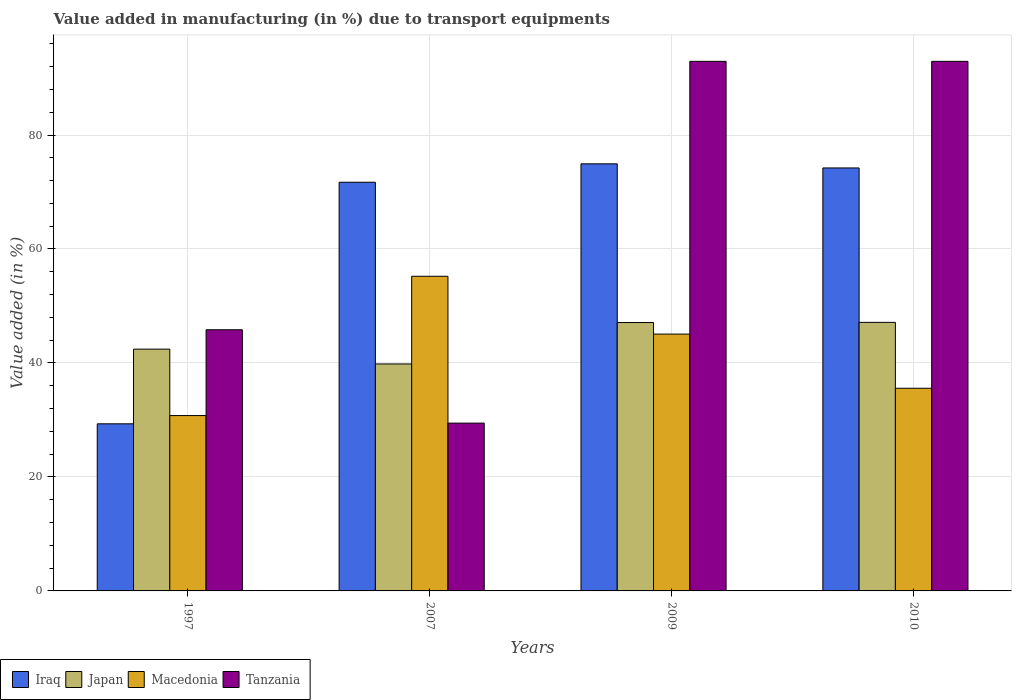How many different coloured bars are there?
Offer a terse response. 4. Are the number of bars per tick equal to the number of legend labels?
Provide a short and direct response. Yes. Are the number of bars on each tick of the X-axis equal?
Offer a terse response. Yes. How many bars are there on the 2nd tick from the left?
Make the answer very short. 4. In how many cases, is the number of bars for a given year not equal to the number of legend labels?
Keep it short and to the point. 0. What is the percentage of value added in manufacturing due to transport equipments in Tanzania in 2010?
Your answer should be very brief. 92.93. Across all years, what is the maximum percentage of value added in manufacturing due to transport equipments in Iraq?
Offer a very short reply. 74.94. Across all years, what is the minimum percentage of value added in manufacturing due to transport equipments in Tanzania?
Your answer should be very brief. 29.44. What is the total percentage of value added in manufacturing due to transport equipments in Iraq in the graph?
Ensure brevity in your answer.  250.2. What is the difference between the percentage of value added in manufacturing due to transport equipments in Tanzania in 1997 and that in 2007?
Make the answer very short. 16.38. What is the difference between the percentage of value added in manufacturing due to transport equipments in Macedonia in 2010 and the percentage of value added in manufacturing due to transport equipments in Iraq in 2009?
Ensure brevity in your answer.  -39.38. What is the average percentage of value added in manufacturing due to transport equipments in Iraq per year?
Ensure brevity in your answer.  62.55. In the year 2010, what is the difference between the percentage of value added in manufacturing due to transport equipments in Iraq and percentage of value added in manufacturing due to transport equipments in Japan?
Your response must be concise. 27.1. What is the ratio of the percentage of value added in manufacturing due to transport equipments in Japan in 2009 to that in 2010?
Provide a succinct answer. 1. Is the percentage of value added in manufacturing due to transport equipments in Japan in 1997 less than that in 2007?
Give a very brief answer. No. Is the difference between the percentage of value added in manufacturing due to transport equipments in Iraq in 1997 and 2009 greater than the difference between the percentage of value added in manufacturing due to transport equipments in Japan in 1997 and 2009?
Give a very brief answer. No. What is the difference between the highest and the second highest percentage of value added in manufacturing due to transport equipments in Iraq?
Provide a succinct answer. 0.72. What is the difference between the highest and the lowest percentage of value added in manufacturing due to transport equipments in Japan?
Provide a succinct answer. 7.3. In how many years, is the percentage of value added in manufacturing due to transport equipments in Japan greater than the average percentage of value added in manufacturing due to transport equipments in Japan taken over all years?
Give a very brief answer. 2. What does the 3rd bar from the right in 2007 represents?
Provide a succinct answer. Japan. Is it the case that in every year, the sum of the percentage of value added in manufacturing due to transport equipments in Japan and percentage of value added in manufacturing due to transport equipments in Tanzania is greater than the percentage of value added in manufacturing due to transport equipments in Macedonia?
Give a very brief answer. Yes. How many bars are there?
Ensure brevity in your answer.  16. What is the difference between two consecutive major ticks on the Y-axis?
Give a very brief answer. 20. Are the values on the major ticks of Y-axis written in scientific E-notation?
Keep it short and to the point. No. How many legend labels are there?
Ensure brevity in your answer.  4. What is the title of the graph?
Make the answer very short. Value added in manufacturing (in %) due to transport equipments. Does "Burundi" appear as one of the legend labels in the graph?
Your response must be concise. No. What is the label or title of the X-axis?
Make the answer very short. Years. What is the label or title of the Y-axis?
Provide a succinct answer. Value added (in %). What is the Value added (in %) in Iraq in 1997?
Offer a very short reply. 29.32. What is the Value added (in %) of Japan in 1997?
Make the answer very short. 42.43. What is the Value added (in %) of Macedonia in 1997?
Ensure brevity in your answer.  30.77. What is the Value added (in %) in Tanzania in 1997?
Provide a short and direct response. 45.83. What is the Value added (in %) in Iraq in 2007?
Your response must be concise. 71.71. What is the Value added (in %) of Japan in 2007?
Offer a terse response. 39.83. What is the Value added (in %) of Macedonia in 2007?
Provide a short and direct response. 55.21. What is the Value added (in %) of Tanzania in 2007?
Provide a succinct answer. 29.44. What is the Value added (in %) in Iraq in 2009?
Your answer should be compact. 74.94. What is the Value added (in %) in Japan in 2009?
Give a very brief answer. 47.1. What is the Value added (in %) in Macedonia in 2009?
Keep it short and to the point. 45.07. What is the Value added (in %) of Tanzania in 2009?
Keep it short and to the point. 92.93. What is the Value added (in %) in Iraq in 2010?
Give a very brief answer. 74.22. What is the Value added (in %) in Japan in 2010?
Keep it short and to the point. 47.12. What is the Value added (in %) of Macedonia in 2010?
Keep it short and to the point. 35.56. What is the Value added (in %) in Tanzania in 2010?
Your answer should be compact. 92.93. Across all years, what is the maximum Value added (in %) of Iraq?
Offer a very short reply. 74.94. Across all years, what is the maximum Value added (in %) of Japan?
Offer a terse response. 47.12. Across all years, what is the maximum Value added (in %) of Macedonia?
Your answer should be compact. 55.21. Across all years, what is the maximum Value added (in %) of Tanzania?
Your answer should be compact. 92.93. Across all years, what is the minimum Value added (in %) of Iraq?
Provide a succinct answer. 29.32. Across all years, what is the minimum Value added (in %) in Japan?
Make the answer very short. 39.83. Across all years, what is the minimum Value added (in %) in Macedonia?
Give a very brief answer. 30.77. Across all years, what is the minimum Value added (in %) in Tanzania?
Give a very brief answer. 29.44. What is the total Value added (in %) of Iraq in the graph?
Your answer should be very brief. 250.2. What is the total Value added (in %) of Japan in the graph?
Offer a terse response. 176.47. What is the total Value added (in %) of Macedonia in the graph?
Your answer should be very brief. 166.61. What is the total Value added (in %) in Tanzania in the graph?
Ensure brevity in your answer.  261.12. What is the difference between the Value added (in %) of Iraq in 1997 and that in 2007?
Make the answer very short. -42.39. What is the difference between the Value added (in %) of Japan in 1997 and that in 2007?
Keep it short and to the point. 2.6. What is the difference between the Value added (in %) of Macedonia in 1997 and that in 2007?
Ensure brevity in your answer.  -24.44. What is the difference between the Value added (in %) in Tanzania in 1997 and that in 2007?
Your answer should be very brief. 16.38. What is the difference between the Value added (in %) of Iraq in 1997 and that in 2009?
Your answer should be compact. -45.62. What is the difference between the Value added (in %) in Japan in 1997 and that in 2009?
Offer a very short reply. -4.67. What is the difference between the Value added (in %) in Macedonia in 1997 and that in 2009?
Your response must be concise. -14.3. What is the difference between the Value added (in %) of Tanzania in 1997 and that in 2009?
Offer a very short reply. -47.1. What is the difference between the Value added (in %) in Iraq in 1997 and that in 2010?
Your answer should be very brief. -44.9. What is the difference between the Value added (in %) in Japan in 1997 and that in 2010?
Your response must be concise. -4.7. What is the difference between the Value added (in %) in Macedonia in 1997 and that in 2010?
Ensure brevity in your answer.  -4.79. What is the difference between the Value added (in %) of Tanzania in 1997 and that in 2010?
Offer a very short reply. -47.1. What is the difference between the Value added (in %) of Iraq in 2007 and that in 2009?
Your response must be concise. -3.23. What is the difference between the Value added (in %) in Japan in 2007 and that in 2009?
Give a very brief answer. -7.27. What is the difference between the Value added (in %) in Macedonia in 2007 and that in 2009?
Your response must be concise. 10.15. What is the difference between the Value added (in %) in Tanzania in 2007 and that in 2009?
Offer a terse response. -63.48. What is the difference between the Value added (in %) in Iraq in 2007 and that in 2010?
Offer a terse response. -2.51. What is the difference between the Value added (in %) of Japan in 2007 and that in 2010?
Give a very brief answer. -7.3. What is the difference between the Value added (in %) in Macedonia in 2007 and that in 2010?
Your answer should be compact. 19.65. What is the difference between the Value added (in %) in Tanzania in 2007 and that in 2010?
Provide a short and direct response. -63.48. What is the difference between the Value added (in %) of Iraq in 2009 and that in 2010?
Ensure brevity in your answer.  0.72. What is the difference between the Value added (in %) in Japan in 2009 and that in 2010?
Your response must be concise. -0.03. What is the difference between the Value added (in %) in Macedonia in 2009 and that in 2010?
Give a very brief answer. 9.51. What is the difference between the Value added (in %) of Tanzania in 2009 and that in 2010?
Ensure brevity in your answer.  -0. What is the difference between the Value added (in %) in Iraq in 1997 and the Value added (in %) in Japan in 2007?
Provide a succinct answer. -10.5. What is the difference between the Value added (in %) of Iraq in 1997 and the Value added (in %) of Macedonia in 2007?
Ensure brevity in your answer.  -25.89. What is the difference between the Value added (in %) in Iraq in 1997 and the Value added (in %) in Tanzania in 2007?
Keep it short and to the point. -0.12. What is the difference between the Value added (in %) of Japan in 1997 and the Value added (in %) of Macedonia in 2007?
Make the answer very short. -12.79. What is the difference between the Value added (in %) of Japan in 1997 and the Value added (in %) of Tanzania in 2007?
Provide a short and direct response. 12.98. What is the difference between the Value added (in %) of Macedonia in 1997 and the Value added (in %) of Tanzania in 2007?
Give a very brief answer. 1.33. What is the difference between the Value added (in %) of Iraq in 1997 and the Value added (in %) of Japan in 2009?
Your answer should be compact. -17.78. What is the difference between the Value added (in %) in Iraq in 1997 and the Value added (in %) in Macedonia in 2009?
Make the answer very short. -15.74. What is the difference between the Value added (in %) in Iraq in 1997 and the Value added (in %) in Tanzania in 2009?
Your answer should be very brief. -63.6. What is the difference between the Value added (in %) in Japan in 1997 and the Value added (in %) in Macedonia in 2009?
Your answer should be very brief. -2.64. What is the difference between the Value added (in %) of Japan in 1997 and the Value added (in %) of Tanzania in 2009?
Your answer should be compact. -50.5. What is the difference between the Value added (in %) in Macedonia in 1997 and the Value added (in %) in Tanzania in 2009?
Your answer should be compact. -62.15. What is the difference between the Value added (in %) in Iraq in 1997 and the Value added (in %) in Japan in 2010?
Your answer should be very brief. -17.8. What is the difference between the Value added (in %) of Iraq in 1997 and the Value added (in %) of Macedonia in 2010?
Ensure brevity in your answer.  -6.24. What is the difference between the Value added (in %) in Iraq in 1997 and the Value added (in %) in Tanzania in 2010?
Give a very brief answer. -63.6. What is the difference between the Value added (in %) in Japan in 1997 and the Value added (in %) in Macedonia in 2010?
Ensure brevity in your answer.  6.86. What is the difference between the Value added (in %) in Japan in 1997 and the Value added (in %) in Tanzania in 2010?
Your answer should be compact. -50.5. What is the difference between the Value added (in %) in Macedonia in 1997 and the Value added (in %) in Tanzania in 2010?
Provide a succinct answer. -62.15. What is the difference between the Value added (in %) in Iraq in 2007 and the Value added (in %) in Japan in 2009?
Give a very brief answer. 24.62. What is the difference between the Value added (in %) of Iraq in 2007 and the Value added (in %) of Macedonia in 2009?
Offer a very short reply. 26.65. What is the difference between the Value added (in %) in Iraq in 2007 and the Value added (in %) in Tanzania in 2009?
Provide a short and direct response. -21.21. What is the difference between the Value added (in %) in Japan in 2007 and the Value added (in %) in Macedonia in 2009?
Offer a terse response. -5.24. What is the difference between the Value added (in %) in Japan in 2007 and the Value added (in %) in Tanzania in 2009?
Your response must be concise. -53.1. What is the difference between the Value added (in %) of Macedonia in 2007 and the Value added (in %) of Tanzania in 2009?
Offer a very short reply. -37.71. What is the difference between the Value added (in %) in Iraq in 2007 and the Value added (in %) in Japan in 2010?
Provide a succinct answer. 24.59. What is the difference between the Value added (in %) of Iraq in 2007 and the Value added (in %) of Macedonia in 2010?
Ensure brevity in your answer.  36.15. What is the difference between the Value added (in %) of Iraq in 2007 and the Value added (in %) of Tanzania in 2010?
Your answer should be compact. -21.21. What is the difference between the Value added (in %) in Japan in 2007 and the Value added (in %) in Macedonia in 2010?
Give a very brief answer. 4.26. What is the difference between the Value added (in %) in Japan in 2007 and the Value added (in %) in Tanzania in 2010?
Provide a succinct answer. -53.1. What is the difference between the Value added (in %) of Macedonia in 2007 and the Value added (in %) of Tanzania in 2010?
Offer a very short reply. -37.71. What is the difference between the Value added (in %) of Iraq in 2009 and the Value added (in %) of Japan in 2010?
Your answer should be very brief. 27.82. What is the difference between the Value added (in %) in Iraq in 2009 and the Value added (in %) in Macedonia in 2010?
Offer a very short reply. 39.38. What is the difference between the Value added (in %) in Iraq in 2009 and the Value added (in %) in Tanzania in 2010?
Provide a short and direct response. -17.98. What is the difference between the Value added (in %) in Japan in 2009 and the Value added (in %) in Macedonia in 2010?
Offer a very short reply. 11.54. What is the difference between the Value added (in %) of Japan in 2009 and the Value added (in %) of Tanzania in 2010?
Offer a terse response. -45.83. What is the difference between the Value added (in %) in Macedonia in 2009 and the Value added (in %) in Tanzania in 2010?
Ensure brevity in your answer.  -47.86. What is the average Value added (in %) of Iraq per year?
Make the answer very short. 62.55. What is the average Value added (in %) in Japan per year?
Keep it short and to the point. 44.12. What is the average Value added (in %) of Macedonia per year?
Provide a short and direct response. 41.65. What is the average Value added (in %) of Tanzania per year?
Offer a very short reply. 65.28. In the year 1997, what is the difference between the Value added (in %) of Iraq and Value added (in %) of Japan?
Give a very brief answer. -13.1. In the year 1997, what is the difference between the Value added (in %) of Iraq and Value added (in %) of Macedonia?
Offer a terse response. -1.45. In the year 1997, what is the difference between the Value added (in %) of Iraq and Value added (in %) of Tanzania?
Provide a short and direct response. -16.5. In the year 1997, what is the difference between the Value added (in %) of Japan and Value added (in %) of Macedonia?
Offer a terse response. 11.66. In the year 1997, what is the difference between the Value added (in %) in Japan and Value added (in %) in Tanzania?
Your answer should be compact. -3.4. In the year 1997, what is the difference between the Value added (in %) in Macedonia and Value added (in %) in Tanzania?
Give a very brief answer. -15.06. In the year 2007, what is the difference between the Value added (in %) in Iraq and Value added (in %) in Japan?
Your response must be concise. 31.89. In the year 2007, what is the difference between the Value added (in %) in Iraq and Value added (in %) in Macedonia?
Give a very brief answer. 16.5. In the year 2007, what is the difference between the Value added (in %) in Iraq and Value added (in %) in Tanzania?
Offer a terse response. 42.27. In the year 2007, what is the difference between the Value added (in %) in Japan and Value added (in %) in Macedonia?
Ensure brevity in your answer.  -15.39. In the year 2007, what is the difference between the Value added (in %) of Japan and Value added (in %) of Tanzania?
Your response must be concise. 10.38. In the year 2007, what is the difference between the Value added (in %) in Macedonia and Value added (in %) in Tanzania?
Your answer should be very brief. 25.77. In the year 2009, what is the difference between the Value added (in %) of Iraq and Value added (in %) of Japan?
Provide a short and direct response. 27.85. In the year 2009, what is the difference between the Value added (in %) in Iraq and Value added (in %) in Macedonia?
Your response must be concise. 29.88. In the year 2009, what is the difference between the Value added (in %) in Iraq and Value added (in %) in Tanzania?
Provide a succinct answer. -17.98. In the year 2009, what is the difference between the Value added (in %) in Japan and Value added (in %) in Macedonia?
Keep it short and to the point. 2.03. In the year 2009, what is the difference between the Value added (in %) in Japan and Value added (in %) in Tanzania?
Your answer should be compact. -45.83. In the year 2009, what is the difference between the Value added (in %) of Macedonia and Value added (in %) of Tanzania?
Your answer should be compact. -47.86. In the year 2010, what is the difference between the Value added (in %) of Iraq and Value added (in %) of Japan?
Offer a terse response. 27.1. In the year 2010, what is the difference between the Value added (in %) in Iraq and Value added (in %) in Macedonia?
Your answer should be compact. 38.66. In the year 2010, what is the difference between the Value added (in %) in Iraq and Value added (in %) in Tanzania?
Provide a succinct answer. -18.7. In the year 2010, what is the difference between the Value added (in %) in Japan and Value added (in %) in Macedonia?
Your answer should be very brief. 11.56. In the year 2010, what is the difference between the Value added (in %) of Japan and Value added (in %) of Tanzania?
Keep it short and to the point. -45.8. In the year 2010, what is the difference between the Value added (in %) in Macedonia and Value added (in %) in Tanzania?
Give a very brief answer. -57.36. What is the ratio of the Value added (in %) of Iraq in 1997 to that in 2007?
Make the answer very short. 0.41. What is the ratio of the Value added (in %) of Japan in 1997 to that in 2007?
Offer a terse response. 1.07. What is the ratio of the Value added (in %) in Macedonia in 1997 to that in 2007?
Provide a succinct answer. 0.56. What is the ratio of the Value added (in %) of Tanzania in 1997 to that in 2007?
Your answer should be very brief. 1.56. What is the ratio of the Value added (in %) in Iraq in 1997 to that in 2009?
Provide a succinct answer. 0.39. What is the ratio of the Value added (in %) of Japan in 1997 to that in 2009?
Keep it short and to the point. 0.9. What is the ratio of the Value added (in %) of Macedonia in 1997 to that in 2009?
Ensure brevity in your answer.  0.68. What is the ratio of the Value added (in %) of Tanzania in 1997 to that in 2009?
Give a very brief answer. 0.49. What is the ratio of the Value added (in %) of Iraq in 1997 to that in 2010?
Keep it short and to the point. 0.4. What is the ratio of the Value added (in %) of Japan in 1997 to that in 2010?
Give a very brief answer. 0.9. What is the ratio of the Value added (in %) in Macedonia in 1997 to that in 2010?
Provide a short and direct response. 0.87. What is the ratio of the Value added (in %) in Tanzania in 1997 to that in 2010?
Provide a succinct answer. 0.49. What is the ratio of the Value added (in %) in Iraq in 2007 to that in 2009?
Offer a terse response. 0.96. What is the ratio of the Value added (in %) in Japan in 2007 to that in 2009?
Your response must be concise. 0.85. What is the ratio of the Value added (in %) in Macedonia in 2007 to that in 2009?
Provide a short and direct response. 1.23. What is the ratio of the Value added (in %) of Tanzania in 2007 to that in 2009?
Provide a succinct answer. 0.32. What is the ratio of the Value added (in %) of Iraq in 2007 to that in 2010?
Your response must be concise. 0.97. What is the ratio of the Value added (in %) of Japan in 2007 to that in 2010?
Keep it short and to the point. 0.85. What is the ratio of the Value added (in %) in Macedonia in 2007 to that in 2010?
Provide a short and direct response. 1.55. What is the ratio of the Value added (in %) in Tanzania in 2007 to that in 2010?
Make the answer very short. 0.32. What is the ratio of the Value added (in %) of Iraq in 2009 to that in 2010?
Offer a very short reply. 1.01. What is the ratio of the Value added (in %) in Macedonia in 2009 to that in 2010?
Make the answer very short. 1.27. What is the difference between the highest and the second highest Value added (in %) in Iraq?
Your answer should be very brief. 0.72. What is the difference between the highest and the second highest Value added (in %) in Japan?
Offer a very short reply. 0.03. What is the difference between the highest and the second highest Value added (in %) of Macedonia?
Your answer should be very brief. 10.15. What is the difference between the highest and the second highest Value added (in %) of Tanzania?
Provide a succinct answer. 0. What is the difference between the highest and the lowest Value added (in %) of Iraq?
Provide a succinct answer. 45.62. What is the difference between the highest and the lowest Value added (in %) of Japan?
Provide a succinct answer. 7.3. What is the difference between the highest and the lowest Value added (in %) of Macedonia?
Provide a short and direct response. 24.44. What is the difference between the highest and the lowest Value added (in %) in Tanzania?
Make the answer very short. 63.48. 